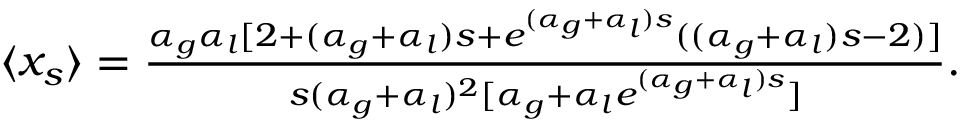<formula> <loc_0><loc_0><loc_500><loc_500>\begin{array} { r } { \langle x _ { s } \rangle = \frac { \alpha _ { g } \alpha _ { l } [ 2 + ( \alpha _ { g } + \alpha _ { l } ) s + e ^ { ( \alpha _ { g } + \alpha _ { l } ) s } ( ( \alpha _ { g } + \alpha _ { l } ) s - 2 ) ] } { s ( \alpha _ { g } + \alpha _ { l } ) ^ { 2 } [ \alpha _ { g } + \alpha _ { l } e ^ { ( \alpha _ { g } + \alpha _ { l } ) s } ] } . } \end{array}</formula> 